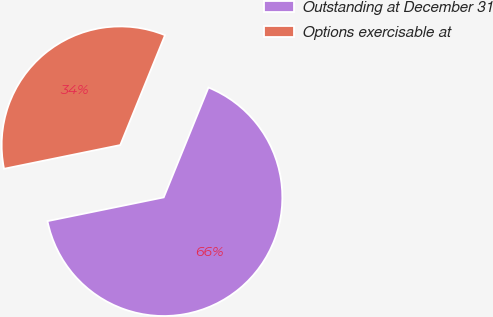<chart> <loc_0><loc_0><loc_500><loc_500><pie_chart><fcel>Outstanding at December 31<fcel>Options exercisable at<nl><fcel>65.64%<fcel>34.36%<nl></chart> 